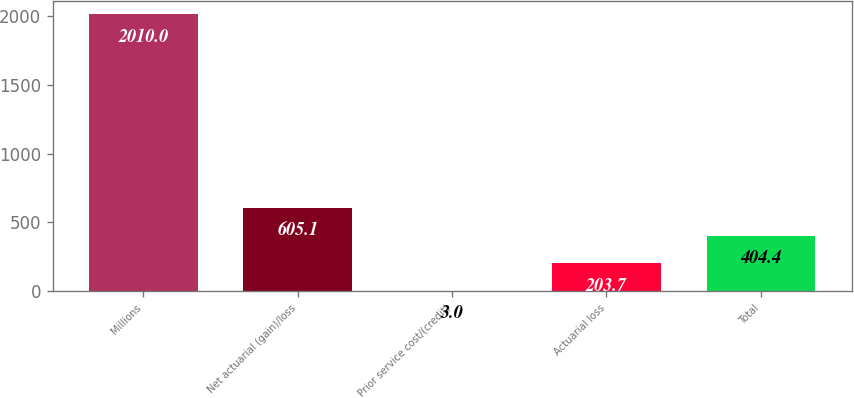<chart> <loc_0><loc_0><loc_500><loc_500><bar_chart><fcel>Millions<fcel>Net actuarial (gain)/loss<fcel>Prior service cost/(credit)<fcel>Actuarial loss<fcel>Total<nl><fcel>2010<fcel>605.1<fcel>3<fcel>203.7<fcel>404.4<nl></chart> 